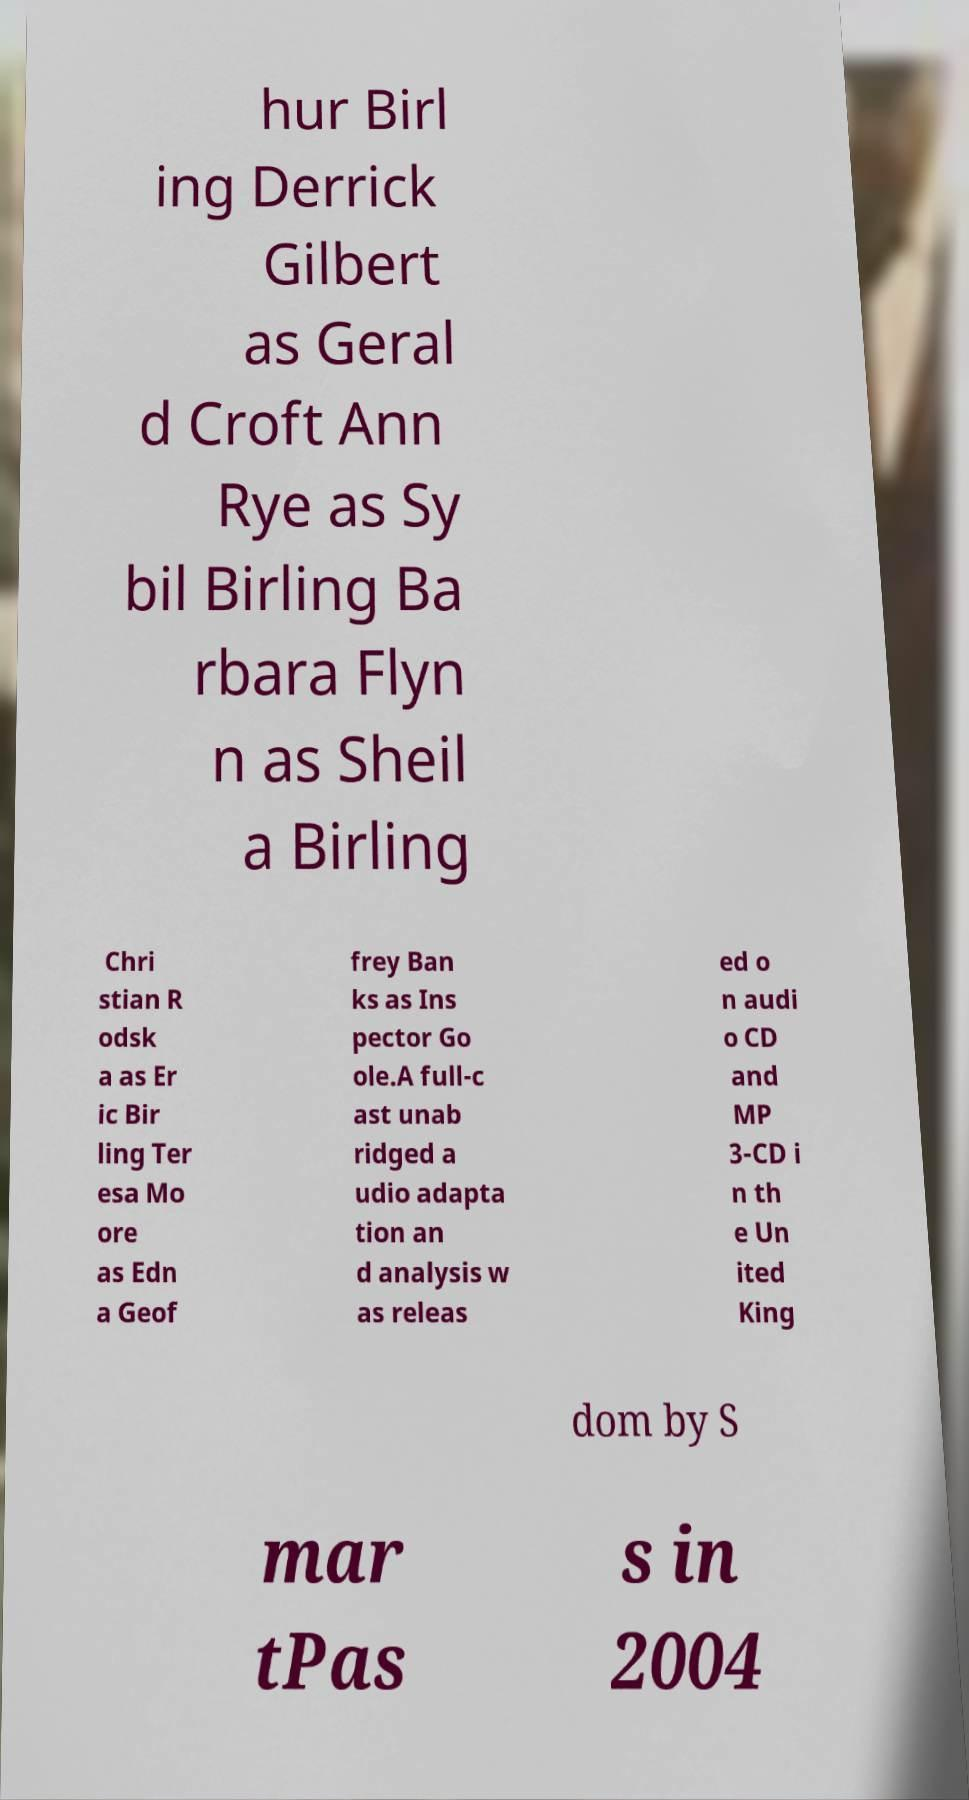What messages or text are displayed in this image? I need them in a readable, typed format. hur Birl ing Derrick Gilbert as Geral d Croft Ann Rye as Sy bil Birling Ba rbara Flyn n as Sheil a Birling Chri stian R odsk a as Er ic Bir ling Ter esa Mo ore as Edn a Geof frey Ban ks as Ins pector Go ole.A full-c ast unab ridged a udio adapta tion an d analysis w as releas ed o n audi o CD and MP 3-CD i n th e Un ited King dom by S mar tPas s in 2004 